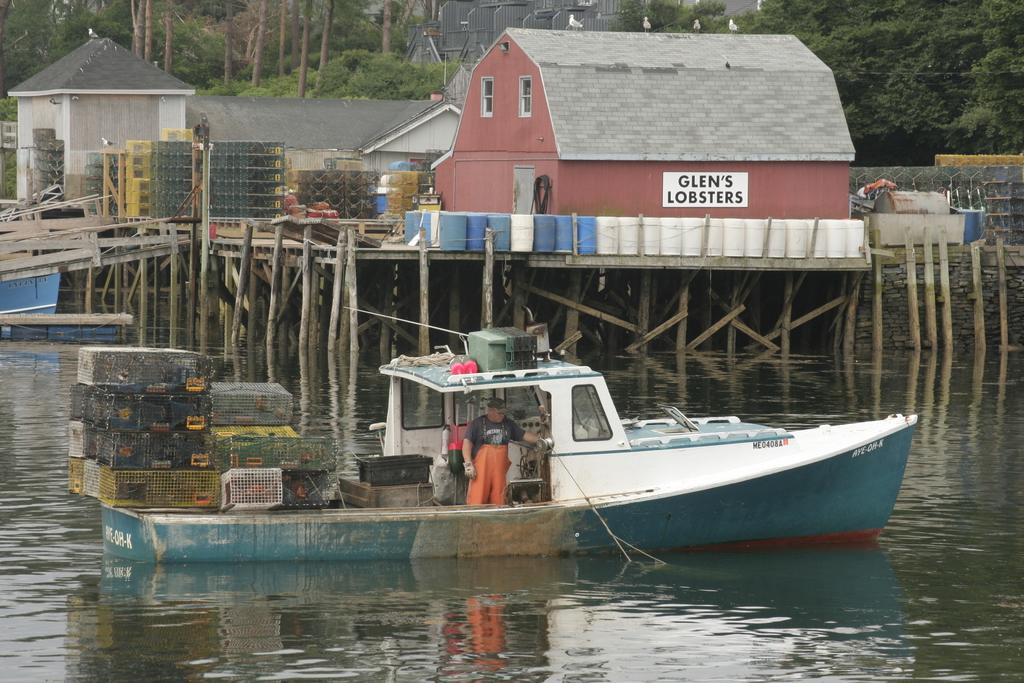What is the main feature of the image? There is water in the image. What is on the water? There is a boat on the water. Who is in the boat? A person is standing in the boat. What can be seen in the background of the image? There are homes and trees visible in the image. How many pages of the yam recipe can be seen in the image? There is no yam recipe or pages present in the image. 